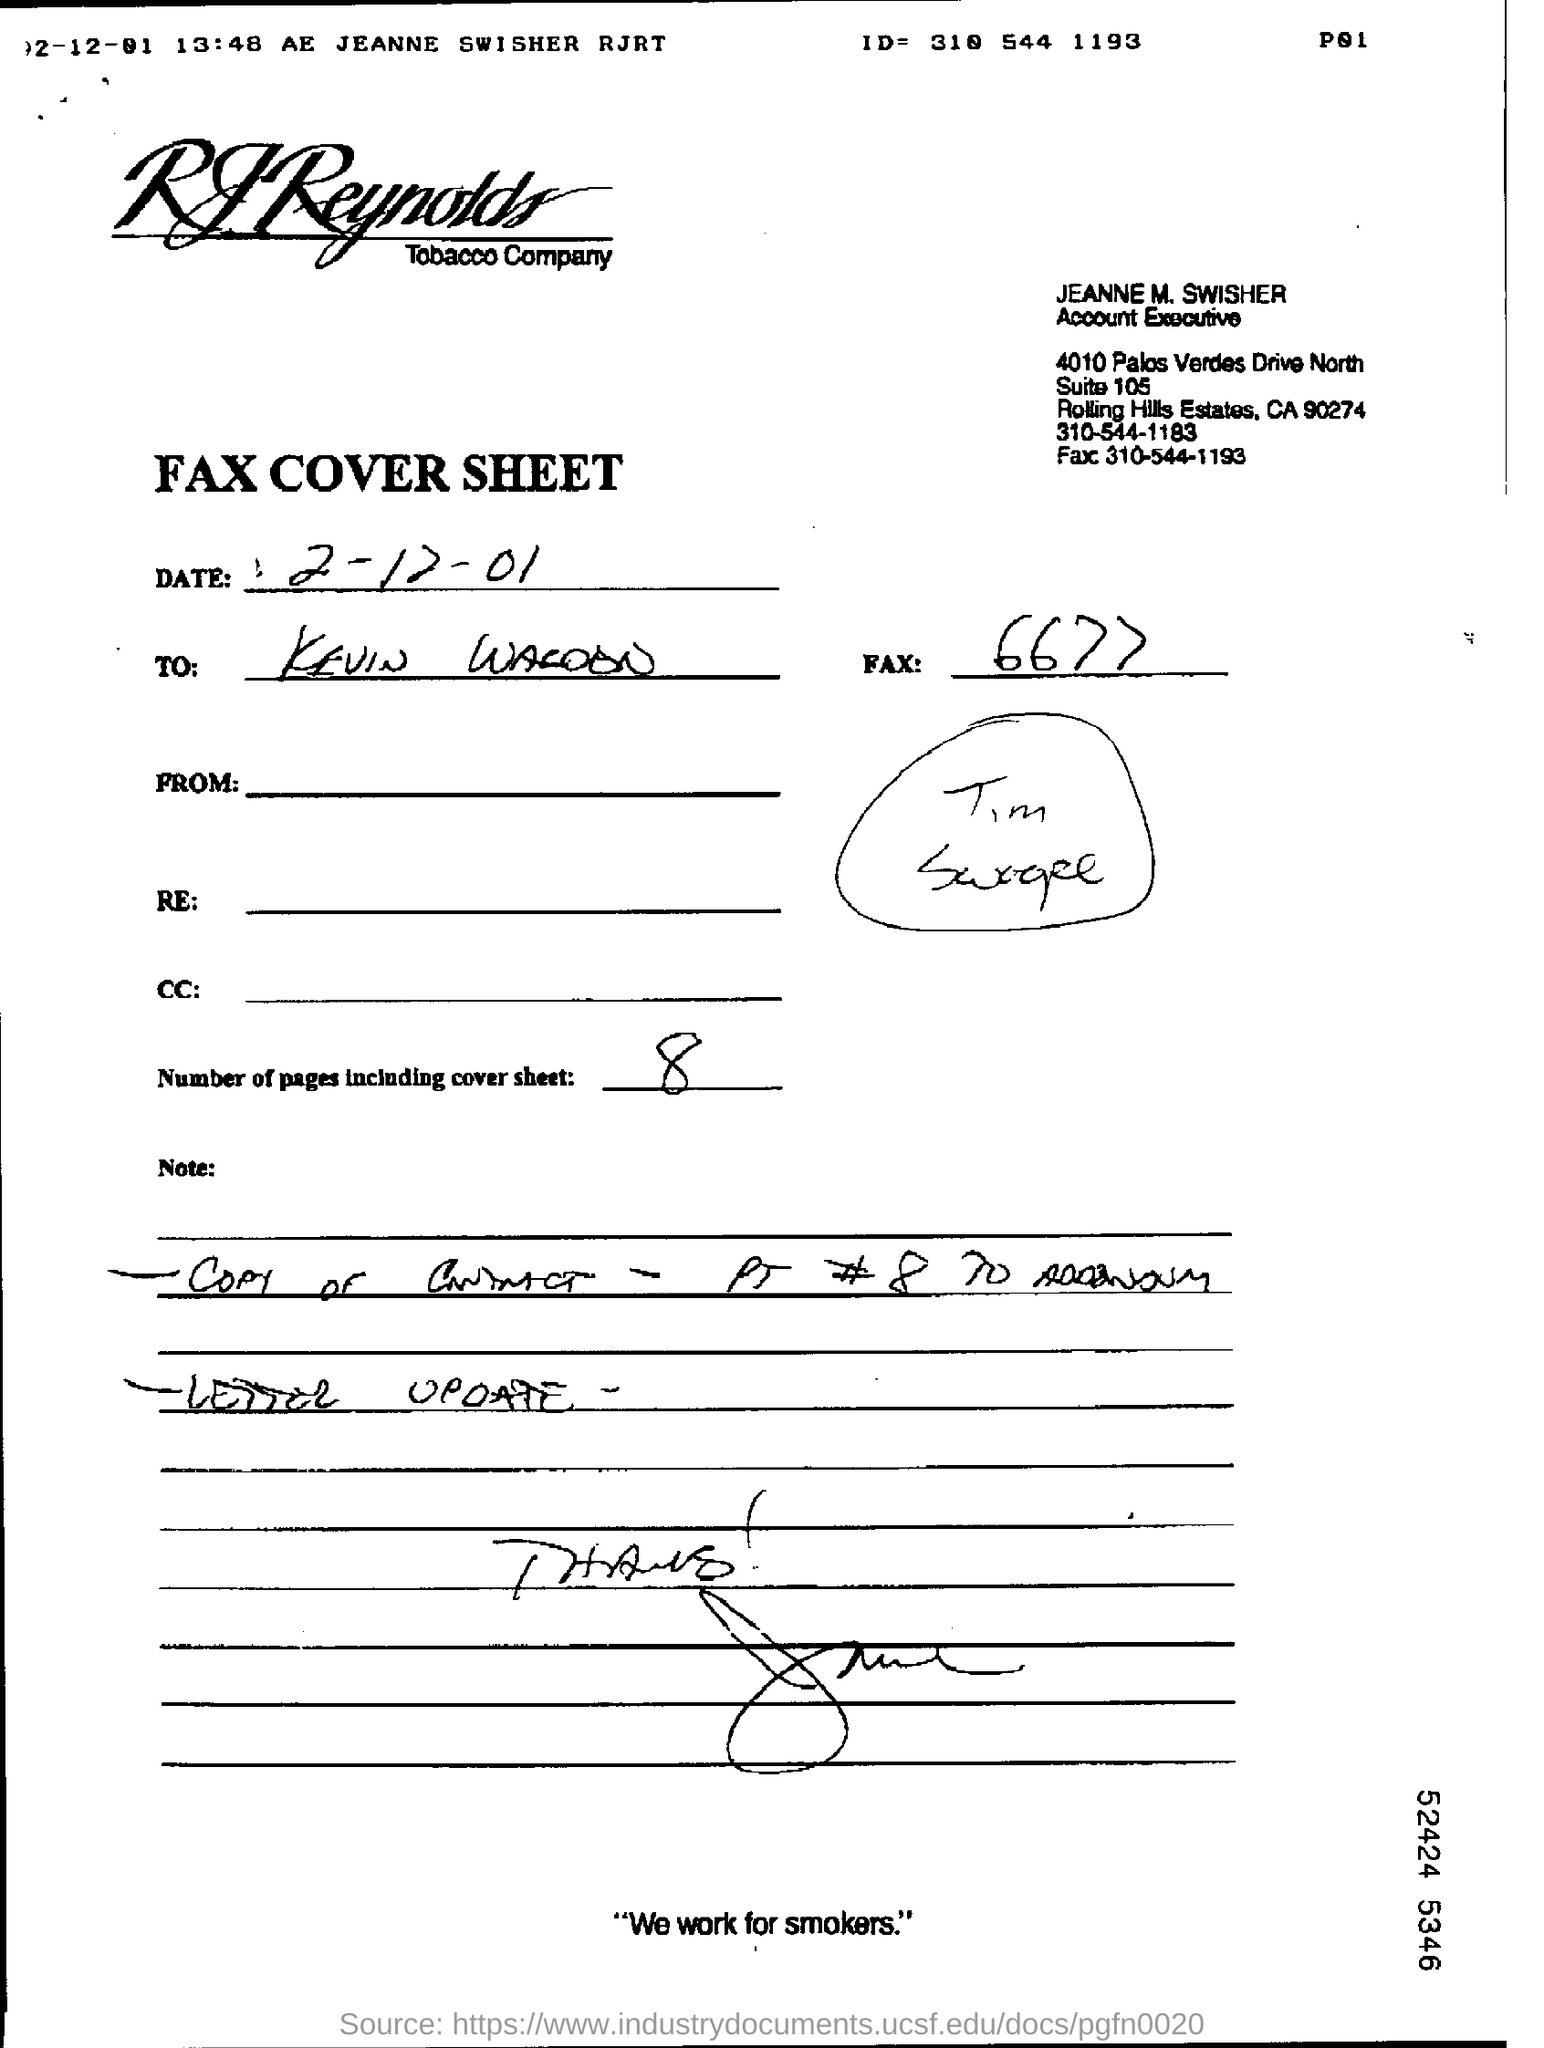What is the desgination of jeanne m. swisher?
Ensure brevity in your answer.  Account Executive. What is the contact number of the jeanne m. swisher
Ensure brevity in your answer.  310-544-1183. What is the name of company?
Give a very brief answer. RJReynolds Tobacco Company. How many pages are including cover sheet?
Your response must be concise. 8. 